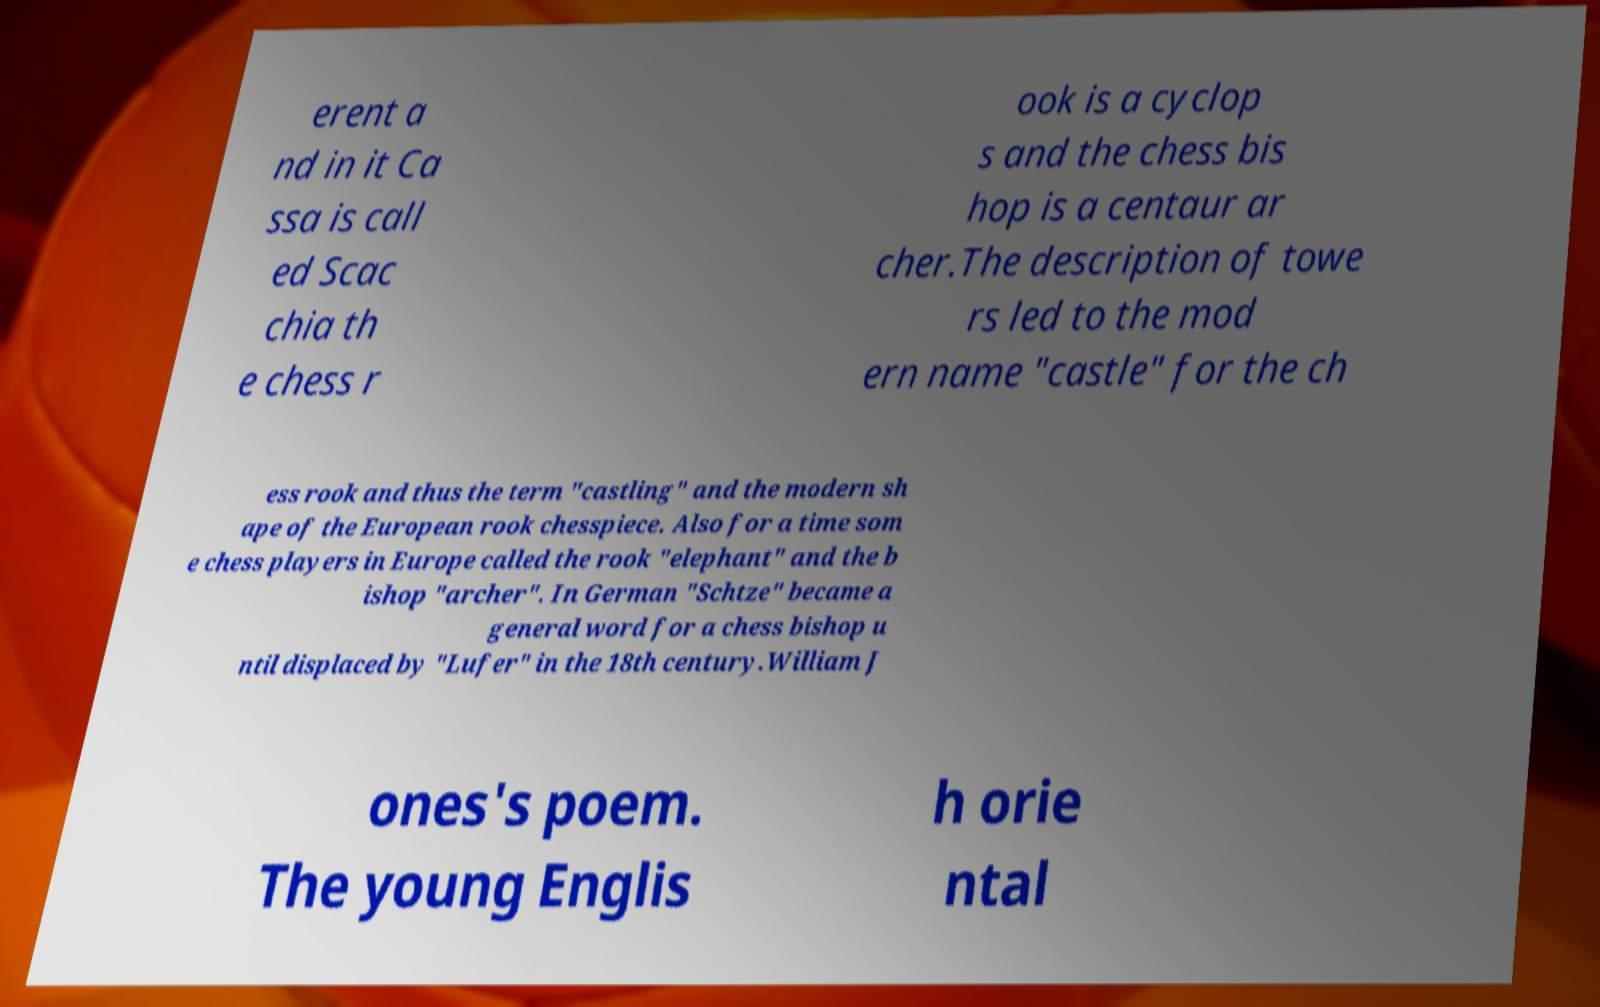Can you read and provide the text displayed in the image?This photo seems to have some interesting text. Can you extract and type it out for me? erent a nd in it Ca ssa is call ed Scac chia th e chess r ook is a cyclop s and the chess bis hop is a centaur ar cher.The description of towe rs led to the mod ern name "castle" for the ch ess rook and thus the term "castling" and the modern sh ape of the European rook chesspiece. Also for a time som e chess players in Europe called the rook "elephant" and the b ishop "archer". In German "Schtze" became a general word for a chess bishop u ntil displaced by "Lufer" in the 18th century.William J ones's poem. The young Englis h orie ntal 